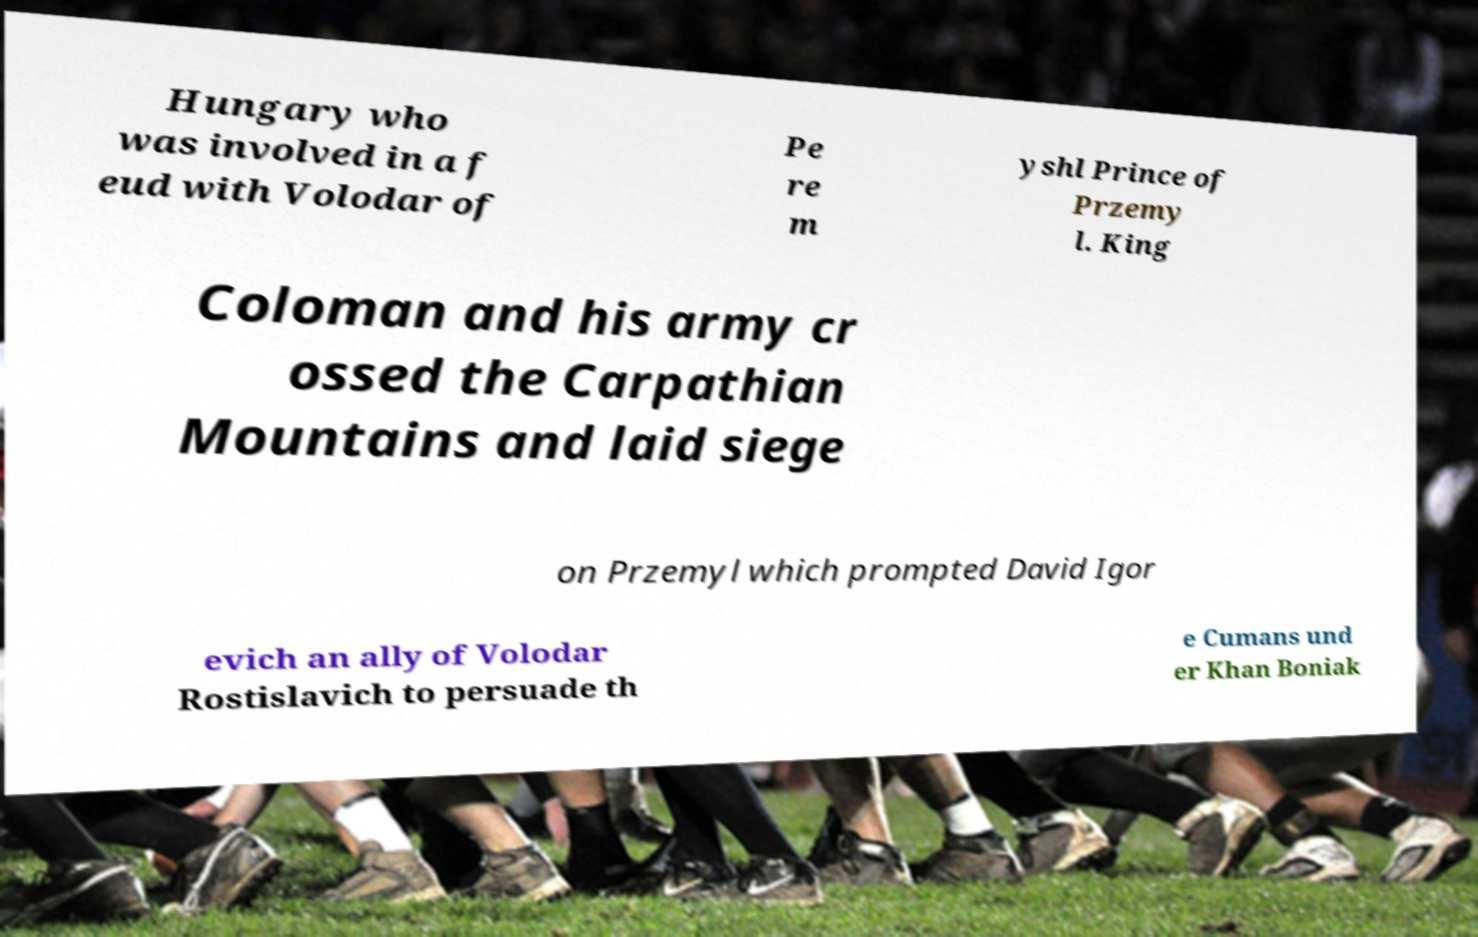Could you extract and type out the text from this image? Hungary who was involved in a f eud with Volodar of Pe re m yshl Prince of Przemy l. King Coloman and his army cr ossed the Carpathian Mountains and laid siege on Przemyl which prompted David Igor evich an ally of Volodar Rostislavich to persuade th e Cumans und er Khan Boniak 